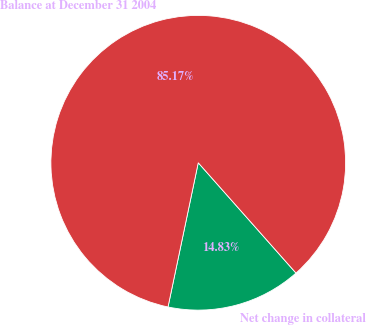Convert chart to OTSL. <chart><loc_0><loc_0><loc_500><loc_500><pie_chart><fcel>Net change in collateral<fcel>Balance at December 31 2004<nl><fcel>14.83%<fcel>85.17%<nl></chart> 